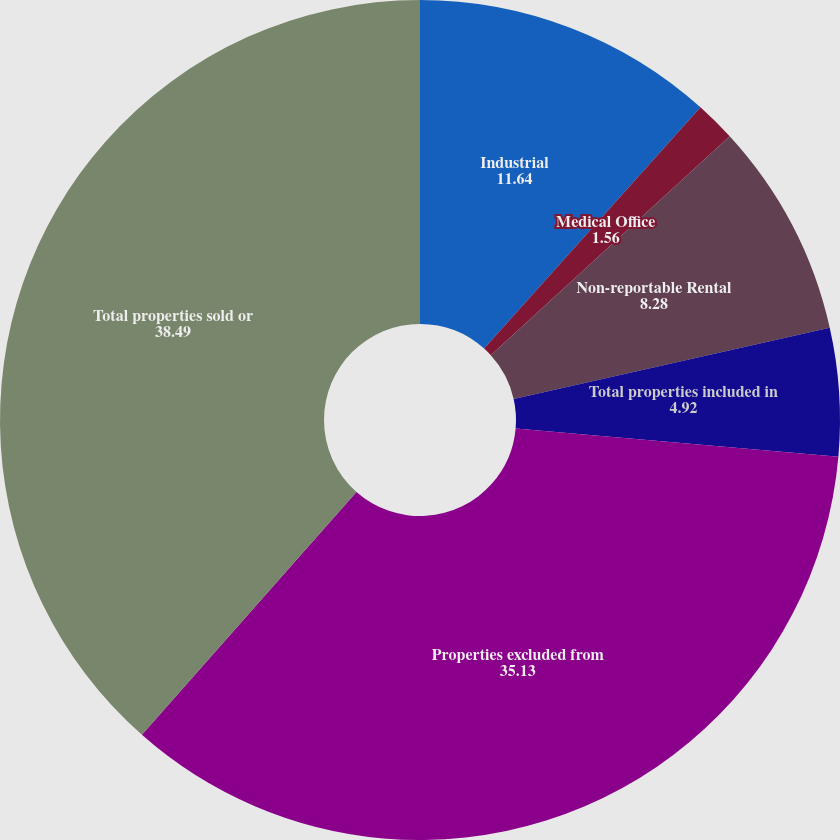<chart> <loc_0><loc_0><loc_500><loc_500><pie_chart><fcel>Industrial<fcel>Medical Office<fcel>Non-reportable Rental<fcel>Total properties included in<fcel>Properties excluded from<fcel>Total properties sold or<nl><fcel>11.64%<fcel>1.56%<fcel>8.28%<fcel>4.92%<fcel>35.13%<fcel>38.49%<nl></chart> 